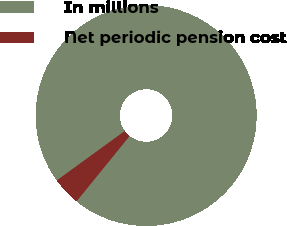Convert chart. <chart><loc_0><loc_0><loc_500><loc_500><pie_chart><fcel>In millions<fcel>Net periodic pension cost<nl><fcel>95.86%<fcel>4.14%<nl></chart> 